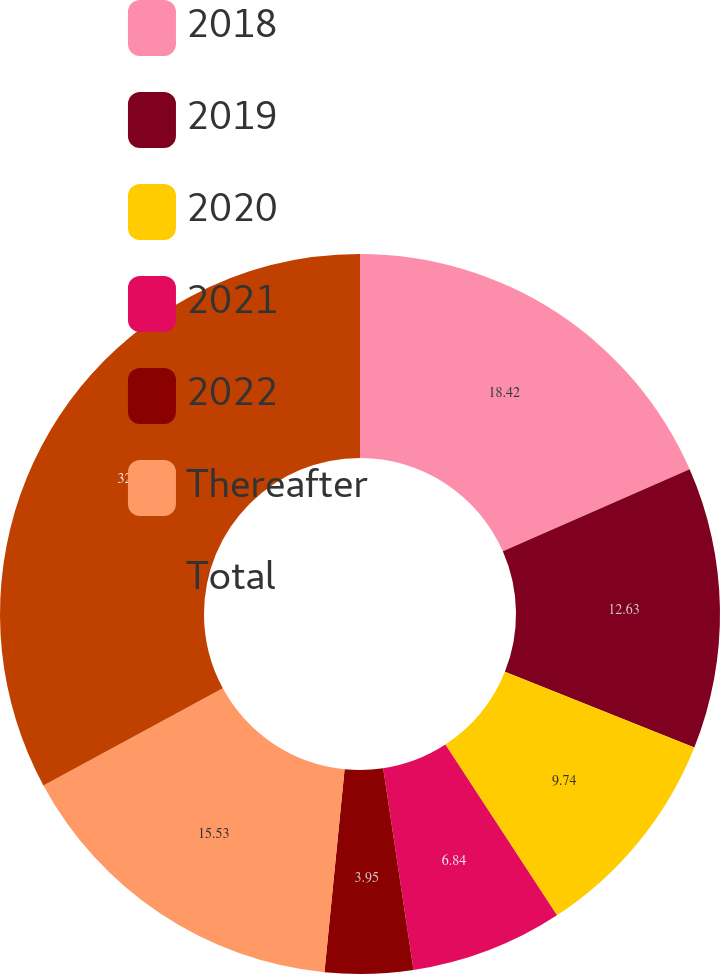Convert chart. <chart><loc_0><loc_0><loc_500><loc_500><pie_chart><fcel>2018<fcel>2019<fcel>2020<fcel>2021<fcel>2022<fcel>Thereafter<fcel>Total<nl><fcel>18.42%<fcel>12.63%<fcel>9.74%<fcel>6.84%<fcel>3.95%<fcel>15.53%<fcel>32.9%<nl></chart> 